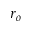<formula> <loc_0><loc_0><loc_500><loc_500>r _ { o }</formula> 